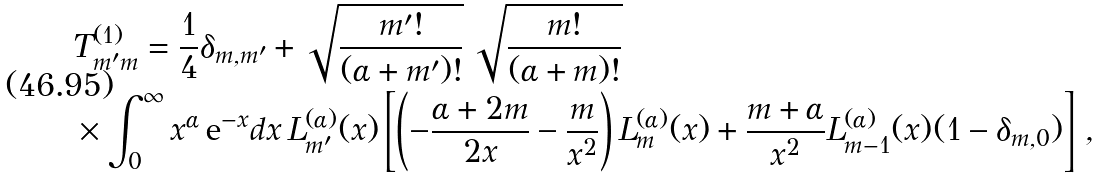<formula> <loc_0><loc_0><loc_500><loc_500>& T ^ { ( 1 ) } _ { m ^ { \prime } m } = \frac { 1 } { 4 } \delta _ { m , m ^ { \prime } } + \sqrt { \frac { m ^ { \prime } ! } { ( \alpha + m ^ { \prime } ) ! } } \, \sqrt { \frac { m ! } { ( \alpha + m ) ! } } \\ & \times \int _ { 0 } ^ { \infty } x ^ { \alpha } \, { \text  e}^{-x} dx\, L^{(\alpha)}_{m^{\prime} } ( x ) \left [ \left ( - \frac { \alpha + 2 m } { 2 x } - \frac { m } { x ^ { 2 } } \right ) L ^ { ( \alpha ) } _ { m } ( x ) + \frac { m + \alpha } { x ^ { 2 } } L ^ { ( \alpha ) } _ { m - 1 } ( x ) ( 1 - \delta _ { m , 0 } ) \right ] \, ,</formula> 